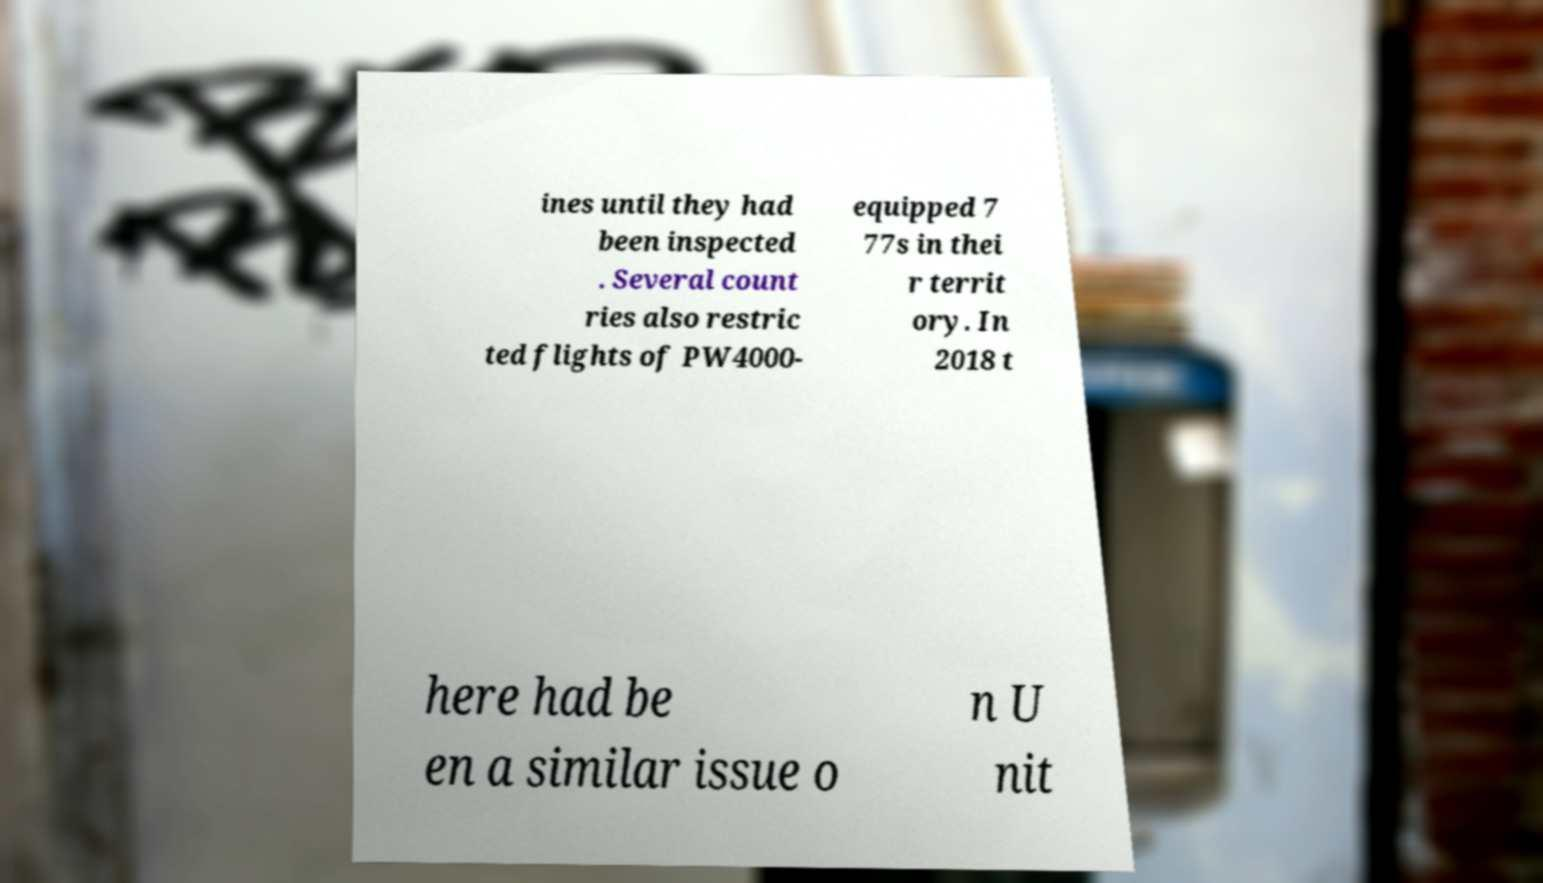For documentation purposes, I need the text within this image transcribed. Could you provide that? ines until they had been inspected . Several count ries also restric ted flights of PW4000- equipped 7 77s in thei r territ ory. In 2018 t here had be en a similar issue o n U nit 